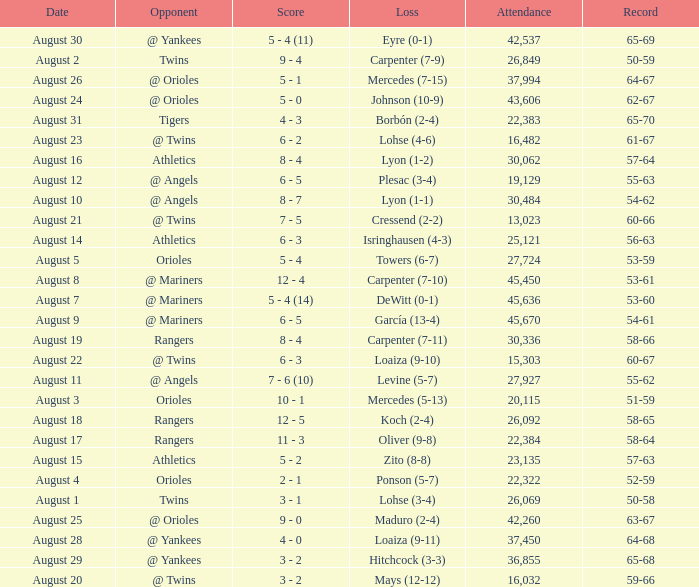What was the score of the game when their record was 62-67 5 - 0. 